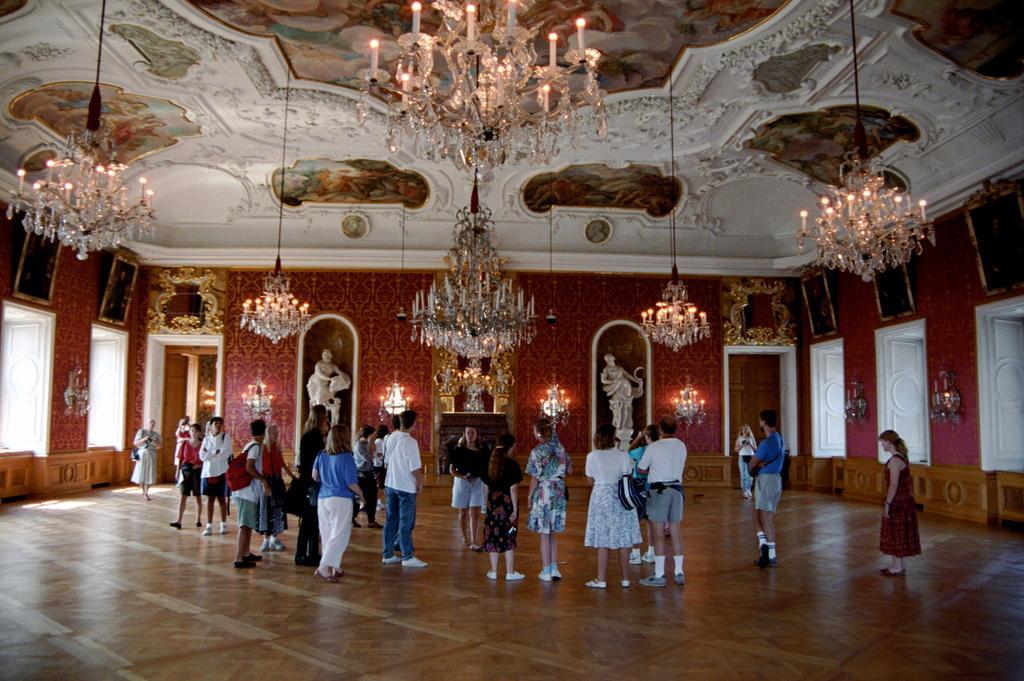Could you give a brief overview of what you see in this image? In this image we can see some group of persons standing in a room in which there are some chandeliers, paintings and some sculptures. 